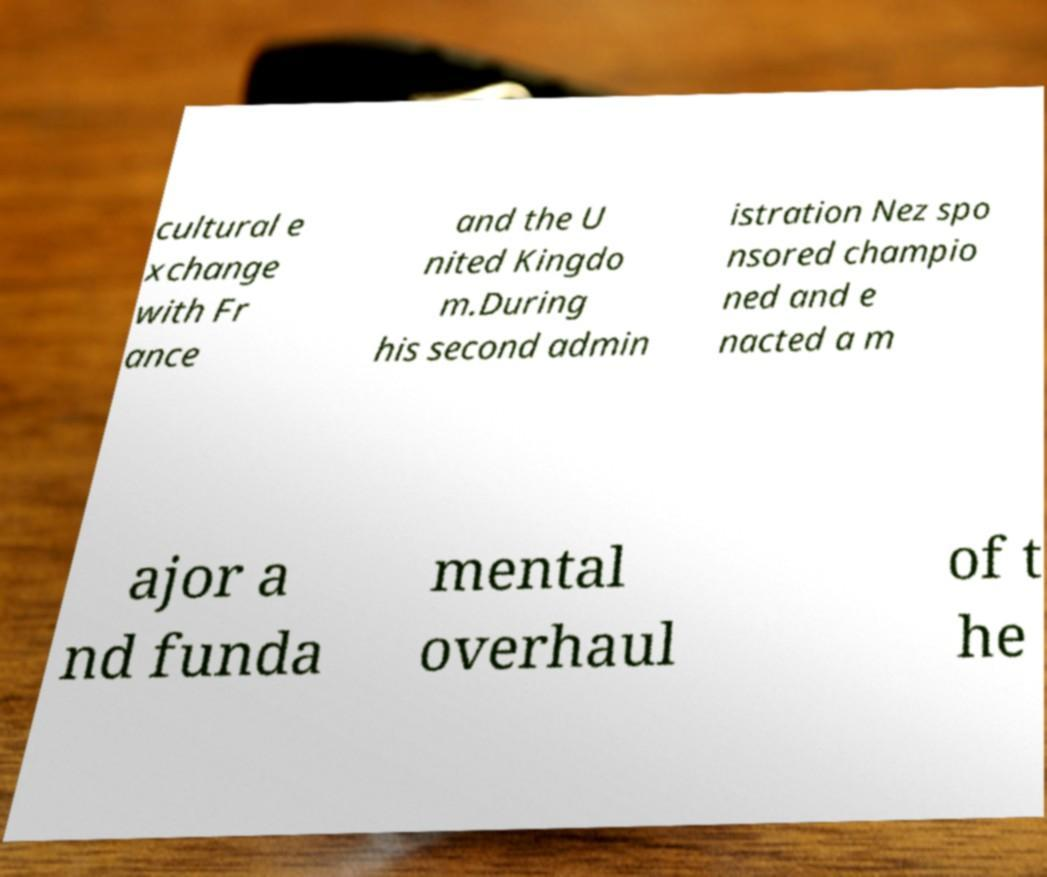Could you extract and type out the text from this image? cultural e xchange with Fr ance and the U nited Kingdo m.During his second admin istration Nez spo nsored champio ned and e nacted a m ajor a nd funda mental overhaul of t he 